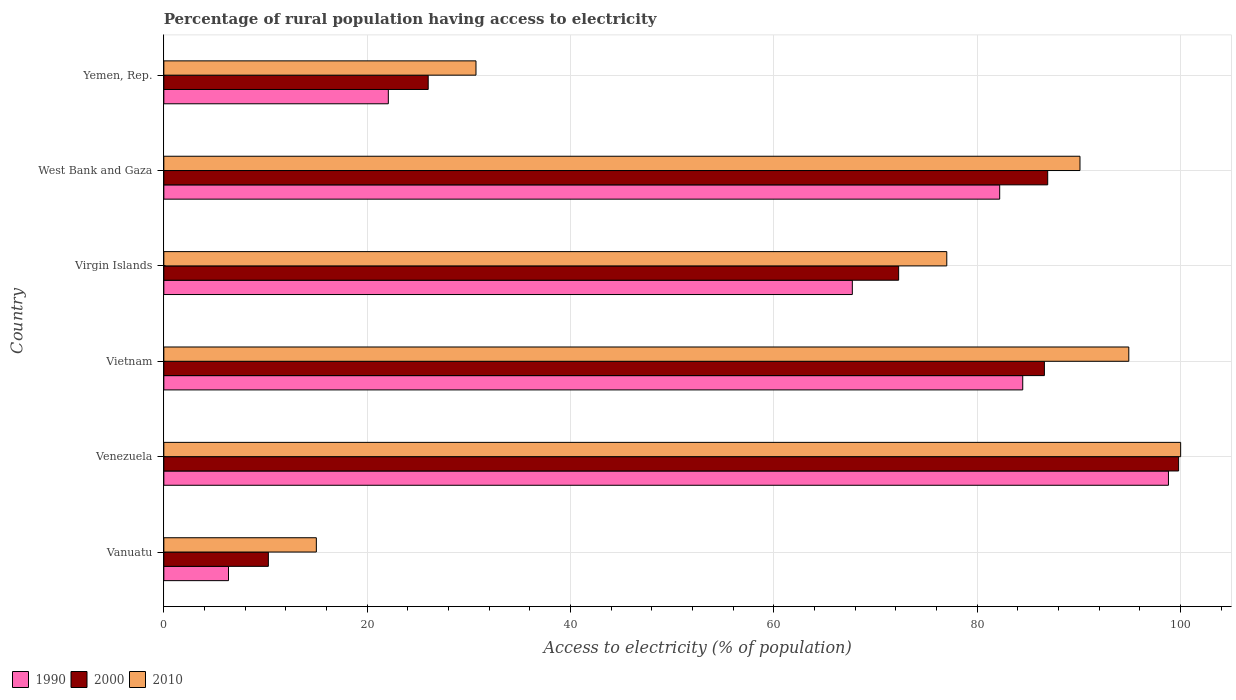Are the number of bars on each tick of the Y-axis equal?
Keep it short and to the point. Yes. What is the label of the 5th group of bars from the top?
Your answer should be very brief. Venezuela. What is the percentage of rural population having access to electricity in 2000 in Vietnam?
Ensure brevity in your answer.  86.6. Across all countries, what is the minimum percentage of rural population having access to electricity in 2010?
Provide a succinct answer. 15. In which country was the percentage of rural population having access to electricity in 2000 maximum?
Your answer should be compact. Venezuela. In which country was the percentage of rural population having access to electricity in 2010 minimum?
Your answer should be very brief. Vanuatu. What is the total percentage of rural population having access to electricity in 2010 in the graph?
Your answer should be compact. 407.7. What is the difference between the percentage of rural population having access to electricity in 1990 in Venezuela and that in West Bank and Gaza?
Your response must be concise. 16.6. What is the difference between the percentage of rural population having access to electricity in 1990 in Yemen, Rep. and the percentage of rural population having access to electricity in 2010 in Venezuela?
Provide a short and direct response. -77.92. What is the average percentage of rural population having access to electricity in 2000 per country?
Offer a very short reply. 63.65. What is the difference between the percentage of rural population having access to electricity in 1990 and percentage of rural population having access to electricity in 2010 in Yemen, Rep.?
Your answer should be compact. -8.62. What is the ratio of the percentage of rural population having access to electricity in 2000 in Virgin Islands to that in Yemen, Rep.?
Give a very brief answer. 2.78. Is the difference between the percentage of rural population having access to electricity in 1990 in Vanuatu and West Bank and Gaza greater than the difference between the percentage of rural population having access to electricity in 2010 in Vanuatu and West Bank and Gaza?
Offer a terse response. No. What is the difference between the highest and the second highest percentage of rural population having access to electricity in 1990?
Keep it short and to the point. 14.33. What is the difference between the highest and the lowest percentage of rural population having access to electricity in 2010?
Give a very brief answer. 85. Is the sum of the percentage of rural population having access to electricity in 2000 in Venezuela and West Bank and Gaza greater than the maximum percentage of rural population having access to electricity in 1990 across all countries?
Your response must be concise. Yes. What does the 1st bar from the top in Venezuela represents?
Your response must be concise. 2010. Is it the case that in every country, the sum of the percentage of rural population having access to electricity in 1990 and percentage of rural population having access to electricity in 2000 is greater than the percentage of rural population having access to electricity in 2010?
Offer a terse response. Yes. How many bars are there?
Offer a very short reply. 18. Are all the bars in the graph horizontal?
Provide a short and direct response. Yes. How many countries are there in the graph?
Provide a short and direct response. 6. Does the graph contain any zero values?
Keep it short and to the point. No. Does the graph contain grids?
Offer a very short reply. Yes. Where does the legend appear in the graph?
Your response must be concise. Bottom left. What is the title of the graph?
Offer a terse response. Percentage of rural population having access to electricity. What is the label or title of the X-axis?
Provide a succinct answer. Access to electricity (% of population). What is the Access to electricity (% of population) of 1990 in Vanuatu?
Your answer should be very brief. 6.36. What is the Access to electricity (% of population) of 2000 in Vanuatu?
Offer a terse response. 10.28. What is the Access to electricity (% of population) of 1990 in Venezuela?
Offer a very short reply. 98.8. What is the Access to electricity (% of population) of 2000 in Venezuela?
Provide a succinct answer. 99.8. What is the Access to electricity (% of population) of 1990 in Vietnam?
Provide a succinct answer. 84.47. What is the Access to electricity (% of population) of 2000 in Vietnam?
Keep it short and to the point. 86.6. What is the Access to electricity (% of population) of 2010 in Vietnam?
Provide a short and direct response. 94.9. What is the Access to electricity (% of population) in 1990 in Virgin Islands?
Your answer should be compact. 67.71. What is the Access to electricity (% of population) in 2000 in Virgin Islands?
Give a very brief answer. 72.27. What is the Access to electricity (% of population) in 2010 in Virgin Islands?
Keep it short and to the point. 77. What is the Access to electricity (% of population) of 1990 in West Bank and Gaza?
Offer a very short reply. 82.2. What is the Access to electricity (% of population) of 2000 in West Bank and Gaza?
Ensure brevity in your answer.  86.93. What is the Access to electricity (% of population) in 2010 in West Bank and Gaza?
Offer a terse response. 90.1. What is the Access to electricity (% of population) of 1990 in Yemen, Rep.?
Offer a terse response. 22.08. What is the Access to electricity (% of population) of 2010 in Yemen, Rep.?
Make the answer very short. 30.7. Across all countries, what is the maximum Access to electricity (% of population) in 1990?
Give a very brief answer. 98.8. Across all countries, what is the maximum Access to electricity (% of population) in 2000?
Ensure brevity in your answer.  99.8. Across all countries, what is the minimum Access to electricity (% of population) in 1990?
Provide a short and direct response. 6.36. Across all countries, what is the minimum Access to electricity (% of population) in 2000?
Provide a succinct answer. 10.28. What is the total Access to electricity (% of population) in 1990 in the graph?
Give a very brief answer. 361.62. What is the total Access to electricity (% of population) in 2000 in the graph?
Your response must be concise. 381.87. What is the total Access to electricity (% of population) of 2010 in the graph?
Offer a terse response. 407.7. What is the difference between the Access to electricity (% of population) of 1990 in Vanuatu and that in Venezuela?
Give a very brief answer. -92.44. What is the difference between the Access to electricity (% of population) of 2000 in Vanuatu and that in Venezuela?
Offer a terse response. -89.52. What is the difference between the Access to electricity (% of population) of 2010 in Vanuatu and that in Venezuela?
Your response must be concise. -85. What is the difference between the Access to electricity (% of population) of 1990 in Vanuatu and that in Vietnam?
Make the answer very short. -78.11. What is the difference between the Access to electricity (% of population) of 2000 in Vanuatu and that in Vietnam?
Your answer should be compact. -76.32. What is the difference between the Access to electricity (% of population) of 2010 in Vanuatu and that in Vietnam?
Your response must be concise. -79.9. What is the difference between the Access to electricity (% of population) of 1990 in Vanuatu and that in Virgin Islands?
Your response must be concise. -61.35. What is the difference between the Access to electricity (% of population) in 2000 in Vanuatu and that in Virgin Islands?
Make the answer very short. -61.98. What is the difference between the Access to electricity (% of population) in 2010 in Vanuatu and that in Virgin Islands?
Provide a succinct answer. -62. What is the difference between the Access to electricity (% of population) of 1990 in Vanuatu and that in West Bank and Gaza?
Make the answer very short. -75.84. What is the difference between the Access to electricity (% of population) of 2000 in Vanuatu and that in West Bank and Gaza?
Provide a short and direct response. -76.65. What is the difference between the Access to electricity (% of population) of 2010 in Vanuatu and that in West Bank and Gaza?
Give a very brief answer. -75.1. What is the difference between the Access to electricity (% of population) of 1990 in Vanuatu and that in Yemen, Rep.?
Offer a terse response. -15.72. What is the difference between the Access to electricity (% of population) in 2000 in Vanuatu and that in Yemen, Rep.?
Ensure brevity in your answer.  -15.72. What is the difference between the Access to electricity (% of population) of 2010 in Vanuatu and that in Yemen, Rep.?
Ensure brevity in your answer.  -15.7. What is the difference between the Access to electricity (% of population) of 1990 in Venezuela and that in Vietnam?
Offer a terse response. 14.33. What is the difference between the Access to electricity (% of population) of 1990 in Venezuela and that in Virgin Islands?
Your answer should be very brief. 31.09. What is the difference between the Access to electricity (% of population) of 2000 in Venezuela and that in Virgin Islands?
Ensure brevity in your answer.  27.54. What is the difference between the Access to electricity (% of population) of 1990 in Venezuela and that in West Bank and Gaza?
Ensure brevity in your answer.  16.6. What is the difference between the Access to electricity (% of population) in 2000 in Venezuela and that in West Bank and Gaza?
Offer a terse response. 12.87. What is the difference between the Access to electricity (% of population) of 2010 in Venezuela and that in West Bank and Gaza?
Make the answer very short. 9.9. What is the difference between the Access to electricity (% of population) in 1990 in Venezuela and that in Yemen, Rep.?
Offer a terse response. 76.72. What is the difference between the Access to electricity (% of population) of 2000 in Venezuela and that in Yemen, Rep.?
Offer a terse response. 73.8. What is the difference between the Access to electricity (% of population) of 2010 in Venezuela and that in Yemen, Rep.?
Give a very brief answer. 69.3. What is the difference between the Access to electricity (% of population) in 1990 in Vietnam and that in Virgin Islands?
Provide a short and direct response. 16.76. What is the difference between the Access to electricity (% of population) of 2000 in Vietnam and that in Virgin Islands?
Provide a succinct answer. 14.34. What is the difference between the Access to electricity (% of population) in 2010 in Vietnam and that in Virgin Islands?
Your answer should be compact. 17.9. What is the difference between the Access to electricity (% of population) in 1990 in Vietnam and that in West Bank and Gaza?
Ensure brevity in your answer.  2.27. What is the difference between the Access to electricity (% of population) of 2000 in Vietnam and that in West Bank and Gaza?
Give a very brief answer. -0.33. What is the difference between the Access to electricity (% of population) of 2010 in Vietnam and that in West Bank and Gaza?
Offer a terse response. 4.8. What is the difference between the Access to electricity (% of population) in 1990 in Vietnam and that in Yemen, Rep.?
Provide a short and direct response. 62.39. What is the difference between the Access to electricity (% of population) in 2000 in Vietnam and that in Yemen, Rep.?
Give a very brief answer. 60.6. What is the difference between the Access to electricity (% of population) in 2010 in Vietnam and that in Yemen, Rep.?
Ensure brevity in your answer.  64.2. What is the difference between the Access to electricity (% of population) of 1990 in Virgin Islands and that in West Bank and Gaza?
Provide a short and direct response. -14.49. What is the difference between the Access to electricity (% of population) of 2000 in Virgin Islands and that in West Bank and Gaza?
Your answer should be very brief. -14.66. What is the difference between the Access to electricity (% of population) of 1990 in Virgin Islands and that in Yemen, Rep.?
Offer a terse response. 45.63. What is the difference between the Access to electricity (% of population) of 2000 in Virgin Islands and that in Yemen, Rep.?
Provide a short and direct response. 46.27. What is the difference between the Access to electricity (% of population) in 2010 in Virgin Islands and that in Yemen, Rep.?
Keep it short and to the point. 46.3. What is the difference between the Access to electricity (% of population) in 1990 in West Bank and Gaza and that in Yemen, Rep.?
Keep it short and to the point. 60.12. What is the difference between the Access to electricity (% of population) in 2000 in West Bank and Gaza and that in Yemen, Rep.?
Provide a short and direct response. 60.93. What is the difference between the Access to electricity (% of population) in 2010 in West Bank and Gaza and that in Yemen, Rep.?
Keep it short and to the point. 59.4. What is the difference between the Access to electricity (% of population) in 1990 in Vanuatu and the Access to electricity (% of population) in 2000 in Venezuela?
Your answer should be compact. -93.44. What is the difference between the Access to electricity (% of population) in 1990 in Vanuatu and the Access to electricity (% of population) in 2010 in Venezuela?
Offer a very short reply. -93.64. What is the difference between the Access to electricity (% of population) of 2000 in Vanuatu and the Access to electricity (% of population) of 2010 in Venezuela?
Keep it short and to the point. -89.72. What is the difference between the Access to electricity (% of population) in 1990 in Vanuatu and the Access to electricity (% of population) in 2000 in Vietnam?
Keep it short and to the point. -80.24. What is the difference between the Access to electricity (% of population) of 1990 in Vanuatu and the Access to electricity (% of population) of 2010 in Vietnam?
Provide a short and direct response. -88.54. What is the difference between the Access to electricity (% of population) of 2000 in Vanuatu and the Access to electricity (% of population) of 2010 in Vietnam?
Offer a very short reply. -84.62. What is the difference between the Access to electricity (% of population) in 1990 in Vanuatu and the Access to electricity (% of population) in 2000 in Virgin Islands?
Provide a short and direct response. -65.9. What is the difference between the Access to electricity (% of population) in 1990 in Vanuatu and the Access to electricity (% of population) in 2010 in Virgin Islands?
Ensure brevity in your answer.  -70.64. What is the difference between the Access to electricity (% of population) in 2000 in Vanuatu and the Access to electricity (% of population) in 2010 in Virgin Islands?
Ensure brevity in your answer.  -66.72. What is the difference between the Access to electricity (% of population) in 1990 in Vanuatu and the Access to electricity (% of population) in 2000 in West Bank and Gaza?
Offer a very short reply. -80.57. What is the difference between the Access to electricity (% of population) of 1990 in Vanuatu and the Access to electricity (% of population) of 2010 in West Bank and Gaza?
Your response must be concise. -83.74. What is the difference between the Access to electricity (% of population) of 2000 in Vanuatu and the Access to electricity (% of population) of 2010 in West Bank and Gaza?
Ensure brevity in your answer.  -79.82. What is the difference between the Access to electricity (% of population) in 1990 in Vanuatu and the Access to electricity (% of population) in 2000 in Yemen, Rep.?
Keep it short and to the point. -19.64. What is the difference between the Access to electricity (% of population) of 1990 in Vanuatu and the Access to electricity (% of population) of 2010 in Yemen, Rep.?
Your answer should be compact. -24.34. What is the difference between the Access to electricity (% of population) in 2000 in Vanuatu and the Access to electricity (% of population) in 2010 in Yemen, Rep.?
Offer a very short reply. -20.42. What is the difference between the Access to electricity (% of population) of 1990 in Venezuela and the Access to electricity (% of population) of 2010 in Vietnam?
Provide a short and direct response. 3.9. What is the difference between the Access to electricity (% of population) in 1990 in Venezuela and the Access to electricity (% of population) in 2000 in Virgin Islands?
Ensure brevity in your answer.  26.54. What is the difference between the Access to electricity (% of population) of 1990 in Venezuela and the Access to electricity (% of population) of 2010 in Virgin Islands?
Provide a short and direct response. 21.8. What is the difference between the Access to electricity (% of population) of 2000 in Venezuela and the Access to electricity (% of population) of 2010 in Virgin Islands?
Provide a succinct answer. 22.8. What is the difference between the Access to electricity (% of population) in 1990 in Venezuela and the Access to electricity (% of population) in 2000 in West Bank and Gaza?
Give a very brief answer. 11.87. What is the difference between the Access to electricity (% of population) of 2000 in Venezuela and the Access to electricity (% of population) of 2010 in West Bank and Gaza?
Ensure brevity in your answer.  9.7. What is the difference between the Access to electricity (% of population) of 1990 in Venezuela and the Access to electricity (% of population) of 2000 in Yemen, Rep.?
Keep it short and to the point. 72.8. What is the difference between the Access to electricity (% of population) of 1990 in Venezuela and the Access to electricity (% of population) of 2010 in Yemen, Rep.?
Your answer should be very brief. 68.1. What is the difference between the Access to electricity (% of population) of 2000 in Venezuela and the Access to electricity (% of population) of 2010 in Yemen, Rep.?
Your response must be concise. 69.1. What is the difference between the Access to electricity (% of population) of 1990 in Vietnam and the Access to electricity (% of population) of 2000 in Virgin Islands?
Offer a terse response. 12.2. What is the difference between the Access to electricity (% of population) in 1990 in Vietnam and the Access to electricity (% of population) in 2010 in Virgin Islands?
Make the answer very short. 7.47. What is the difference between the Access to electricity (% of population) in 2000 in Vietnam and the Access to electricity (% of population) in 2010 in Virgin Islands?
Ensure brevity in your answer.  9.6. What is the difference between the Access to electricity (% of population) in 1990 in Vietnam and the Access to electricity (% of population) in 2000 in West Bank and Gaza?
Your response must be concise. -2.46. What is the difference between the Access to electricity (% of population) of 1990 in Vietnam and the Access to electricity (% of population) of 2010 in West Bank and Gaza?
Offer a terse response. -5.63. What is the difference between the Access to electricity (% of population) in 1990 in Vietnam and the Access to electricity (% of population) in 2000 in Yemen, Rep.?
Offer a very short reply. 58.47. What is the difference between the Access to electricity (% of population) of 1990 in Vietnam and the Access to electricity (% of population) of 2010 in Yemen, Rep.?
Provide a succinct answer. 53.77. What is the difference between the Access to electricity (% of population) in 2000 in Vietnam and the Access to electricity (% of population) in 2010 in Yemen, Rep.?
Offer a very short reply. 55.9. What is the difference between the Access to electricity (% of population) of 1990 in Virgin Islands and the Access to electricity (% of population) of 2000 in West Bank and Gaza?
Provide a succinct answer. -19.21. What is the difference between the Access to electricity (% of population) of 1990 in Virgin Islands and the Access to electricity (% of population) of 2010 in West Bank and Gaza?
Offer a terse response. -22.39. What is the difference between the Access to electricity (% of population) of 2000 in Virgin Islands and the Access to electricity (% of population) of 2010 in West Bank and Gaza?
Offer a very short reply. -17.84. What is the difference between the Access to electricity (% of population) of 1990 in Virgin Islands and the Access to electricity (% of population) of 2000 in Yemen, Rep.?
Your response must be concise. 41.71. What is the difference between the Access to electricity (% of population) in 1990 in Virgin Islands and the Access to electricity (% of population) in 2010 in Yemen, Rep.?
Offer a terse response. 37.01. What is the difference between the Access to electricity (% of population) of 2000 in Virgin Islands and the Access to electricity (% of population) of 2010 in Yemen, Rep.?
Provide a short and direct response. 41.56. What is the difference between the Access to electricity (% of population) in 1990 in West Bank and Gaza and the Access to electricity (% of population) in 2000 in Yemen, Rep.?
Provide a short and direct response. 56.2. What is the difference between the Access to electricity (% of population) of 1990 in West Bank and Gaza and the Access to electricity (% of population) of 2010 in Yemen, Rep.?
Your answer should be very brief. 51.5. What is the difference between the Access to electricity (% of population) in 2000 in West Bank and Gaza and the Access to electricity (% of population) in 2010 in Yemen, Rep.?
Offer a very short reply. 56.23. What is the average Access to electricity (% of population) in 1990 per country?
Offer a terse response. 60.27. What is the average Access to electricity (% of population) in 2000 per country?
Your answer should be very brief. 63.65. What is the average Access to electricity (% of population) of 2010 per country?
Provide a short and direct response. 67.95. What is the difference between the Access to electricity (% of population) in 1990 and Access to electricity (% of population) in 2000 in Vanuatu?
Make the answer very short. -3.92. What is the difference between the Access to electricity (% of population) in 1990 and Access to electricity (% of population) in 2010 in Vanuatu?
Ensure brevity in your answer.  -8.64. What is the difference between the Access to electricity (% of population) of 2000 and Access to electricity (% of population) of 2010 in Vanuatu?
Your response must be concise. -4.72. What is the difference between the Access to electricity (% of population) of 1990 and Access to electricity (% of population) of 2000 in Venezuela?
Provide a succinct answer. -1. What is the difference between the Access to electricity (% of population) of 1990 and Access to electricity (% of population) of 2010 in Venezuela?
Offer a terse response. -1.2. What is the difference between the Access to electricity (% of population) in 2000 and Access to electricity (% of population) in 2010 in Venezuela?
Ensure brevity in your answer.  -0.2. What is the difference between the Access to electricity (% of population) in 1990 and Access to electricity (% of population) in 2000 in Vietnam?
Provide a succinct answer. -2.13. What is the difference between the Access to electricity (% of population) in 1990 and Access to electricity (% of population) in 2010 in Vietnam?
Offer a very short reply. -10.43. What is the difference between the Access to electricity (% of population) in 2000 and Access to electricity (% of population) in 2010 in Vietnam?
Offer a terse response. -8.3. What is the difference between the Access to electricity (% of population) of 1990 and Access to electricity (% of population) of 2000 in Virgin Islands?
Ensure brevity in your answer.  -4.55. What is the difference between the Access to electricity (% of population) in 1990 and Access to electricity (% of population) in 2010 in Virgin Islands?
Your response must be concise. -9.29. What is the difference between the Access to electricity (% of population) in 2000 and Access to electricity (% of population) in 2010 in Virgin Islands?
Ensure brevity in your answer.  -4.74. What is the difference between the Access to electricity (% of population) in 1990 and Access to electricity (% of population) in 2000 in West Bank and Gaza?
Offer a terse response. -4.72. What is the difference between the Access to electricity (% of population) in 1990 and Access to electricity (% of population) in 2010 in West Bank and Gaza?
Ensure brevity in your answer.  -7.9. What is the difference between the Access to electricity (% of population) of 2000 and Access to electricity (% of population) of 2010 in West Bank and Gaza?
Provide a succinct answer. -3.17. What is the difference between the Access to electricity (% of population) of 1990 and Access to electricity (% of population) of 2000 in Yemen, Rep.?
Provide a succinct answer. -3.92. What is the difference between the Access to electricity (% of population) of 1990 and Access to electricity (% of population) of 2010 in Yemen, Rep.?
Offer a terse response. -8.62. What is the difference between the Access to electricity (% of population) in 2000 and Access to electricity (% of population) in 2010 in Yemen, Rep.?
Keep it short and to the point. -4.7. What is the ratio of the Access to electricity (% of population) in 1990 in Vanuatu to that in Venezuela?
Provide a short and direct response. 0.06. What is the ratio of the Access to electricity (% of population) in 2000 in Vanuatu to that in Venezuela?
Provide a short and direct response. 0.1. What is the ratio of the Access to electricity (% of population) of 2010 in Vanuatu to that in Venezuela?
Give a very brief answer. 0.15. What is the ratio of the Access to electricity (% of population) in 1990 in Vanuatu to that in Vietnam?
Keep it short and to the point. 0.08. What is the ratio of the Access to electricity (% of population) in 2000 in Vanuatu to that in Vietnam?
Provide a succinct answer. 0.12. What is the ratio of the Access to electricity (% of population) of 2010 in Vanuatu to that in Vietnam?
Provide a short and direct response. 0.16. What is the ratio of the Access to electricity (% of population) in 1990 in Vanuatu to that in Virgin Islands?
Your answer should be compact. 0.09. What is the ratio of the Access to electricity (% of population) of 2000 in Vanuatu to that in Virgin Islands?
Provide a succinct answer. 0.14. What is the ratio of the Access to electricity (% of population) in 2010 in Vanuatu to that in Virgin Islands?
Offer a very short reply. 0.19. What is the ratio of the Access to electricity (% of population) of 1990 in Vanuatu to that in West Bank and Gaza?
Give a very brief answer. 0.08. What is the ratio of the Access to electricity (% of population) in 2000 in Vanuatu to that in West Bank and Gaza?
Give a very brief answer. 0.12. What is the ratio of the Access to electricity (% of population) of 2010 in Vanuatu to that in West Bank and Gaza?
Provide a succinct answer. 0.17. What is the ratio of the Access to electricity (% of population) in 1990 in Vanuatu to that in Yemen, Rep.?
Ensure brevity in your answer.  0.29. What is the ratio of the Access to electricity (% of population) of 2000 in Vanuatu to that in Yemen, Rep.?
Your answer should be compact. 0.4. What is the ratio of the Access to electricity (% of population) of 2010 in Vanuatu to that in Yemen, Rep.?
Your response must be concise. 0.49. What is the ratio of the Access to electricity (% of population) in 1990 in Venezuela to that in Vietnam?
Ensure brevity in your answer.  1.17. What is the ratio of the Access to electricity (% of population) in 2000 in Venezuela to that in Vietnam?
Keep it short and to the point. 1.15. What is the ratio of the Access to electricity (% of population) in 2010 in Venezuela to that in Vietnam?
Ensure brevity in your answer.  1.05. What is the ratio of the Access to electricity (% of population) in 1990 in Venezuela to that in Virgin Islands?
Provide a succinct answer. 1.46. What is the ratio of the Access to electricity (% of population) in 2000 in Venezuela to that in Virgin Islands?
Your response must be concise. 1.38. What is the ratio of the Access to electricity (% of population) of 2010 in Venezuela to that in Virgin Islands?
Ensure brevity in your answer.  1.3. What is the ratio of the Access to electricity (% of population) in 1990 in Venezuela to that in West Bank and Gaza?
Make the answer very short. 1.2. What is the ratio of the Access to electricity (% of population) in 2000 in Venezuela to that in West Bank and Gaza?
Keep it short and to the point. 1.15. What is the ratio of the Access to electricity (% of population) of 2010 in Venezuela to that in West Bank and Gaza?
Make the answer very short. 1.11. What is the ratio of the Access to electricity (% of population) of 1990 in Venezuela to that in Yemen, Rep.?
Your answer should be compact. 4.47. What is the ratio of the Access to electricity (% of population) in 2000 in Venezuela to that in Yemen, Rep.?
Make the answer very short. 3.84. What is the ratio of the Access to electricity (% of population) in 2010 in Venezuela to that in Yemen, Rep.?
Your answer should be very brief. 3.26. What is the ratio of the Access to electricity (% of population) of 1990 in Vietnam to that in Virgin Islands?
Keep it short and to the point. 1.25. What is the ratio of the Access to electricity (% of population) of 2000 in Vietnam to that in Virgin Islands?
Your answer should be very brief. 1.2. What is the ratio of the Access to electricity (% of population) in 2010 in Vietnam to that in Virgin Islands?
Provide a short and direct response. 1.23. What is the ratio of the Access to electricity (% of population) of 1990 in Vietnam to that in West Bank and Gaza?
Your answer should be very brief. 1.03. What is the ratio of the Access to electricity (% of population) of 2010 in Vietnam to that in West Bank and Gaza?
Keep it short and to the point. 1.05. What is the ratio of the Access to electricity (% of population) of 1990 in Vietnam to that in Yemen, Rep.?
Provide a succinct answer. 3.83. What is the ratio of the Access to electricity (% of population) of 2000 in Vietnam to that in Yemen, Rep.?
Ensure brevity in your answer.  3.33. What is the ratio of the Access to electricity (% of population) of 2010 in Vietnam to that in Yemen, Rep.?
Offer a terse response. 3.09. What is the ratio of the Access to electricity (% of population) in 1990 in Virgin Islands to that in West Bank and Gaza?
Ensure brevity in your answer.  0.82. What is the ratio of the Access to electricity (% of population) in 2000 in Virgin Islands to that in West Bank and Gaza?
Your response must be concise. 0.83. What is the ratio of the Access to electricity (% of population) in 2010 in Virgin Islands to that in West Bank and Gaza?
Your answer should be very brief. 0.85. What is the ratio of the Access to electricity (% of population) in 1990 in Virgin Islands to that in Yemen, Rep.?
Your answer should be very brief. 3.07. What is the ratio of the Access to electricity (% of population) of 2000 in Virgin Islands to that in Yemen, Rep.?
Offer a terse response. 2.78. What is the ratio of the Access to electricity (% of population) in 2010 in Virgin Islands to that in Yemen, Rep.?
Provide a succinct answer. 2.51. What is the ratio of the Access to electricity (% of population) in 1990 in West Bank and Gaza to that in Yemen, Rep.?
Make the answer very short. 3.72. What is the ratio of the Access to electricity (% of population) in 2000 in West Bank and Gaza to that in Yemen, Rep.?
Ensure brevity in your answer.  3.34. What is the ratio of the Access to electricity (% of population) of 2010 in West Bank and Gaza to that in Yemen, Rep.?
Provide a succinct answer. 2.93. What is the difference between the highest and the second highest Access to electricity (% of population) in 1990?
Provide a short and direct response. 14.33. What is the difference between the highest and the second highest Access to electricity (% of population) in 2000?
Make the answer very short. 12.87. What is the difference between the highest and the lowest Access to electricity (% of population) in 1990?
Offer a terse response. 92.44. What is the difference between the highest and the lowest Access to electricity (% of population) in 2000?
Make the answer very short. 89.52. What is the difference between the highest and the lowest Access to electricity (% of population) of 2010?
Give a very brief answer. 85. 